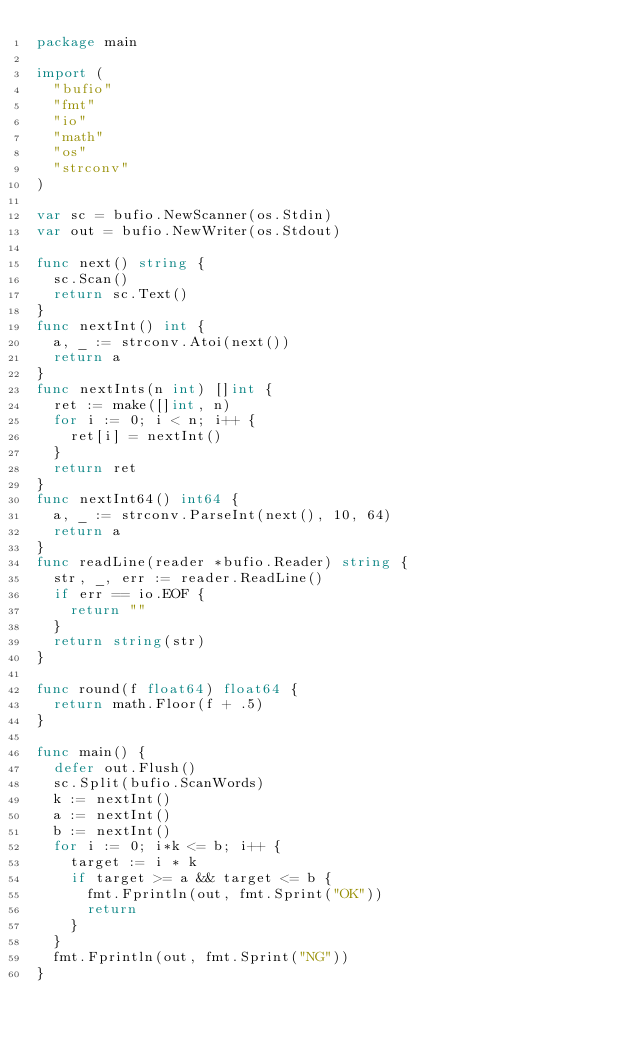<code> <loc_0><loc_0><loc_500><loc_500><_Go_>package main

import (
	"bufio"
	"fmt"
	"io"
	"math"
	"os"
	"strconv"
)

var sc = bufio.NewScanner(os.Stdin)
var out = bufio.NewWriter(os.Stdout)

func next() string {
	sc.Scan()
	return sc.Text()
}
func nextInt() int {
	a, _ := strconv.Atoi(next())
	return a
}
func nextInts(n int) []int {
	ret := make([]int, n)
	for i := 0; i < n; i++ {
		ret[i] = nextInt()
	}
	return ret
}
func nextInt64() int64 {
	a, _ := strconv.ParseInt(next(), 10, 64)
	return a
}
func readLine(reader *bufio.Reader) string {
	str, _, err := reader.ReadLine()
	if err == io.EOF {
		return ""
	}
	return string(str)
}

func round(f float64) float64 {
	return math.Floor(f + .5)
}

func main() {
	defer out.Flush()
	sc.Split(bufio.ScanWords)
	k := nextInt()
	a := nextInt()
	b := nextInt()
	for i := 0; i*k <= b; i++ {
		target := i * k
		if target >= a && target <= b {
			fmt.Fprintln(out, fmt.Sprint("OK"))
			return
		}
	}
	fmt.Fprintln(out, fmt.Sprint("NG"))
}
</code> 